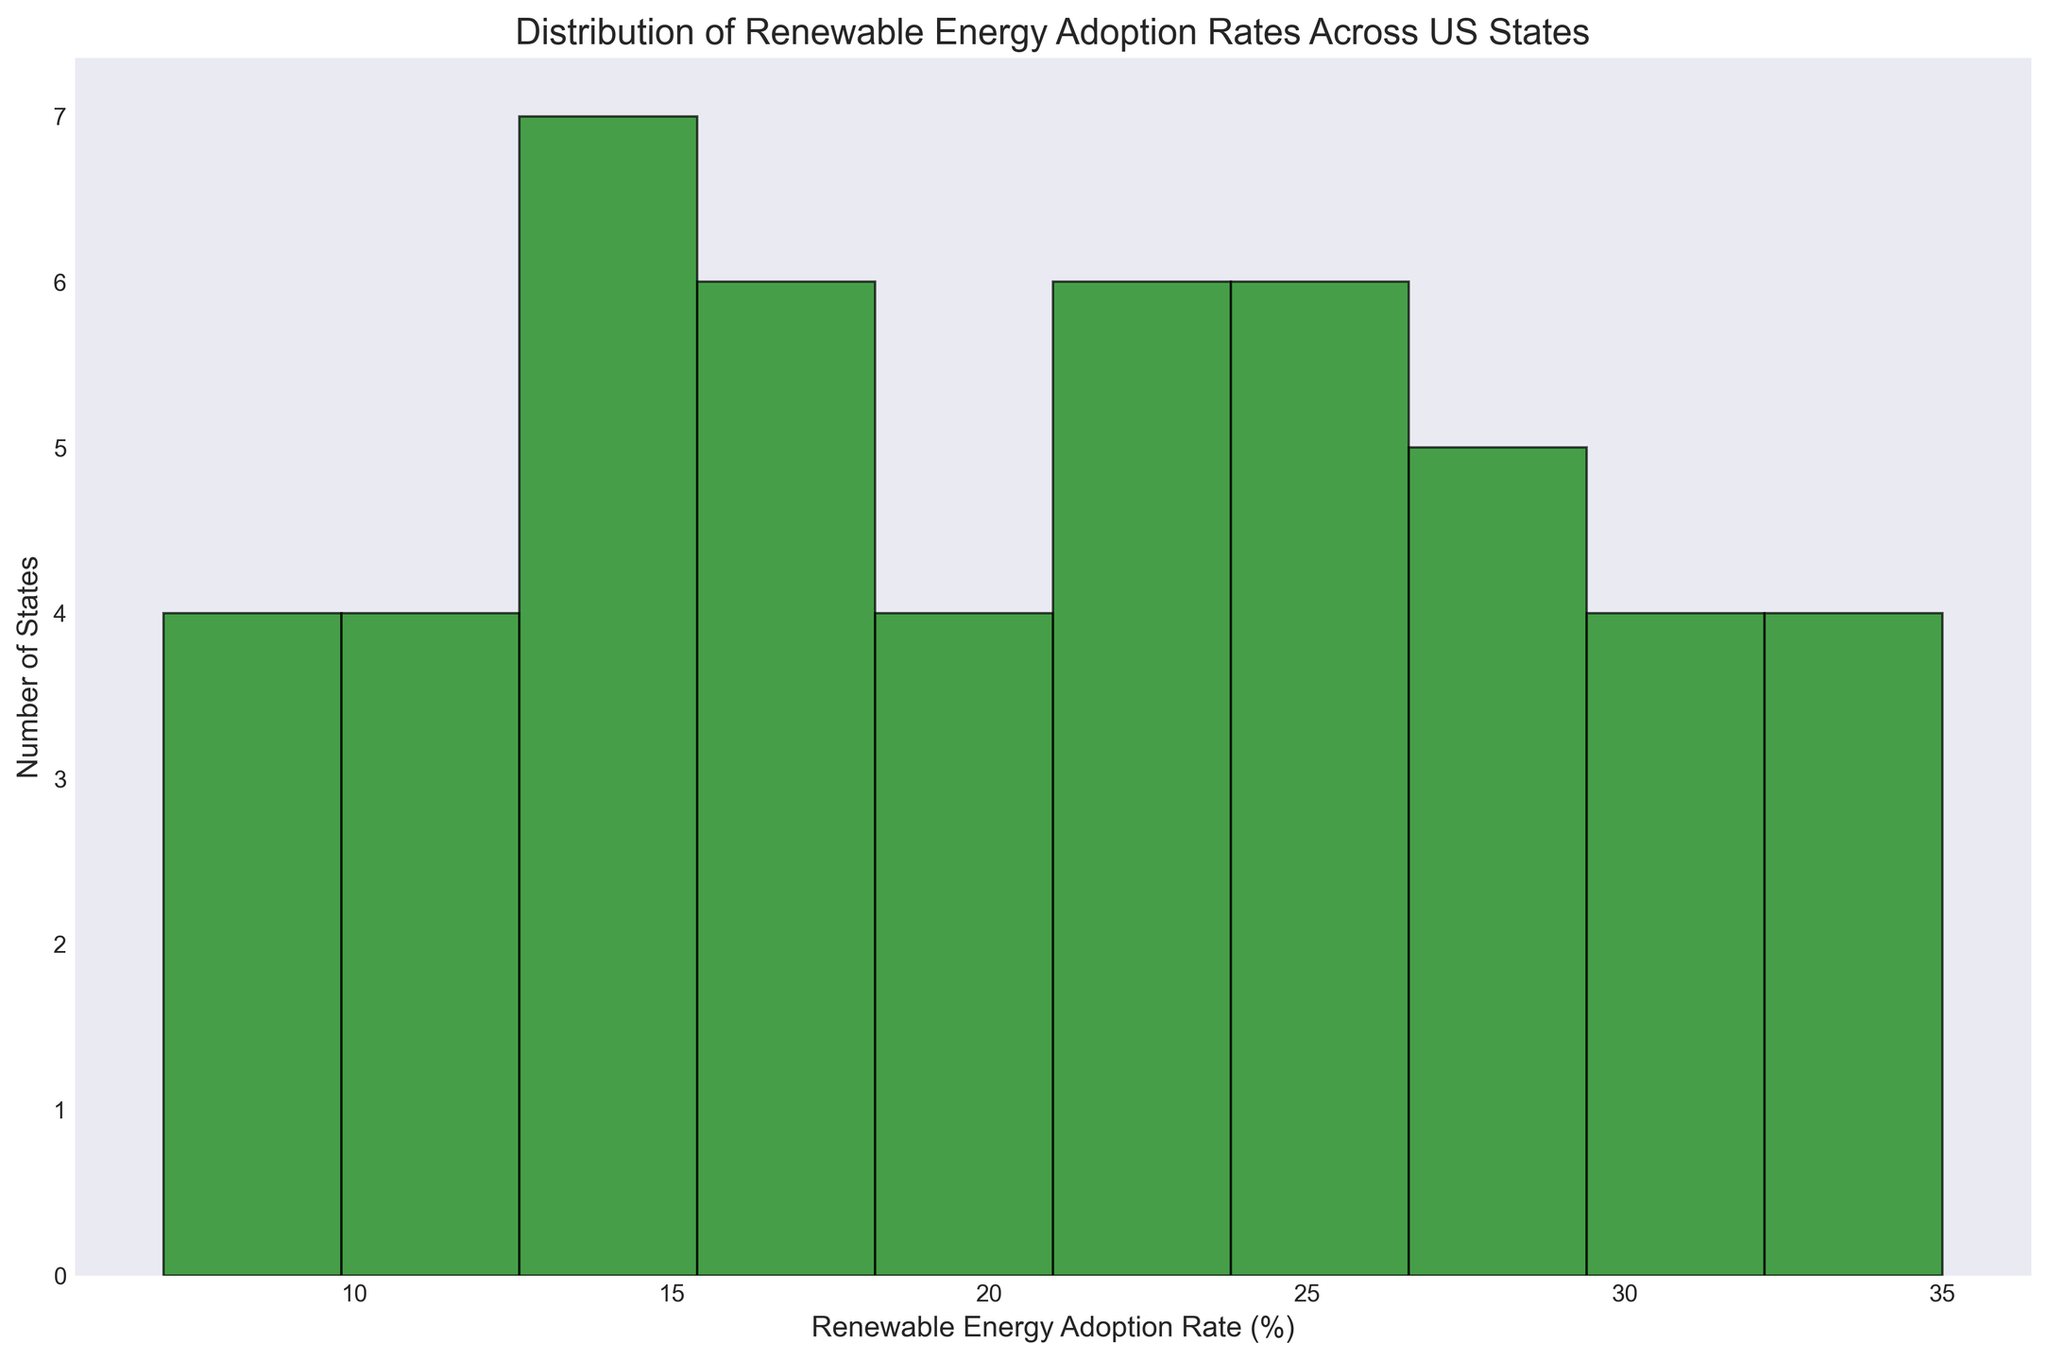What's the most common range of Renewable Energy Adoption Rates across US states? First, observe which bar is the tallest in the histogram since the height of each bar represents the number of states within a particular rate range. The tallest bar indicates the most frequent range.
Answer: 20-25% How many states have a renewable energy adoption rate of 30% or higher? Identify and count the bars that represent adoption rates of 30% or higher on the histogram's x-axis. Sum up the heights (number of states) of these bars.
Answer: 8 states Which range has the least number of states adopting renewable energy? Look for the shortest bar in the histogram, as it represents the range with the least number of states.
Answer: 5-10% Compare the number of states with adoption rates below 15% and above 25%. Which is greater? First, count the total number of states in bars representing adoption rates below 15%. Then, count the states in bars representing rates above 25%. Compare these two sums.
Answer: Above 25% What's the average Renewable Energy Adoption Rate for the range with the highest number of states adopting renewable energy? Identify the range with the highest number of states (the tallest bar), then find the midpoint of this range, as it represents the average adoption rate for that range.
Answer: 22.5% Does any single adoption rate range contain more than one-third of all states? Count the total number of states represented in the histogram. If a single bar (a range) contains more than 1/3 of this total, it exceeds one-third. Usually, compare the tallest bar against the total states.
Answer: No How does the number of states with adoption rates between 15% and 20% compare to those between 20% and 25%? Count the states within the 15-20% range and those in the 20-25% range by examining the height of the corresponding bars. Compare these counts.
Answer: 20-25% is greater What is the total number of states represented in the histogram? Sum the heights of all the bars in the histogram as each bar height represents the number of states in that range.
Answer: 51 states What percentage of states have an adoption rate less than 10%? Count the states in the bars for adoption rates less than 10%. Divide this by the total number of states and multiply by 100 to get the percentage.
Answer: 4% Is the distribution of Renewable Energy Adoption Rates skewed towards higher or lower values? Observe the overall shape of the histogram. If more states are clustered towards the lower or higher end of the adoption rates, it indicates skewness.
Answer: Higher values 